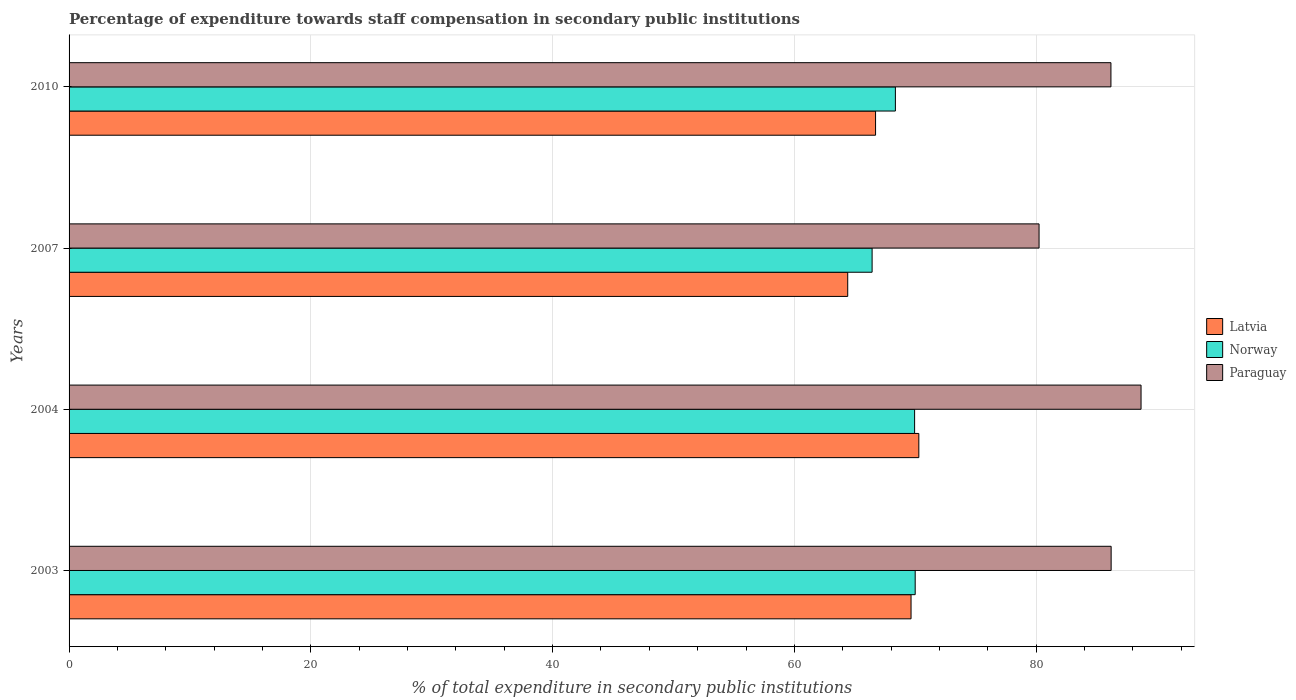How many different coloured bars are there?
Keep it short and to the point. 3. How many groups of bars are there?
Provide a succinct answer. 4. Are the number of bars per tick equal to the number of legend labels?
Your answer should be compact. Yes. Are the number of bars on each tick of the Y-axis equal?
Offer a very short reply. Yes. What is the label of the 3rd group of bars from the top?
Give a very brief answer. 2004. What is the percentage of expenditure towards staff compensation in Latvia in 2003?
Ensure brevity in your answer.  69.65. Across all years, what is the maximum percentage of expenditure towards staff compensation in Norway?
Your answer should be compact. 70. Across all years, what is the minimum percentage of expenditure towards staff compensation in Norway?
Your answer should be very brief. 66.43. In which year was the percentage of expenditure towards staff compensation in Latvia maximum?
Offer a terse response. 2004. What is the total percentage of expenditure towards staff compensation in Latvia in the graph?
Your response must be concise. 271.08. What is the difference between the percentage of expenditure towards staff compensation in Paraguay in 2004 and that in 2010?
Keep it short and to the point. 2.49. What is the difference between the percentage of expenditure towards staff compensation in Latvia in 2010 and the percentage of expenditure towards staff compensation in Norway in 2003?
Ensure brevity in your answer.  -3.28. What is the average percentage of expenditure towards staff compensation in Latvia per year?
Offer a very short reply. 67.77. In the year 2007, what is the difference between the percentage of expenditure towards staff compensation in Norway and percentage of expenditure towards staff compensation in Latvia?
Make the answer very short. 2.02. What is the ratio of the percentage of expenditure towards staff compensation in Latvia in 2003 to that in 2004?
Ensure brevity in your answer.  0.99. Is the difference between the percentage of expenditure towards staff compensation in Norway in 2003 and 2010 greater than the difference between the percentage of expenditure towards staff compensation in Latvia in 2003 and 2010?
Offer a terse response. No. What is the difference between the highest and the second highest percentage of expenditure towards staff compensation in Paraguay?
Your answer should be compact. 2.47. What is the difference between the highest and the lowest percentage of expenditure towards staff compensation in Latvia?
Make the answer very short. 5.88. In how many years, is the percentage of expenditure towards staff compensation in Latvia greater than the average percentage of expenditure towards staff compensation in Latvia taken over all years?
Your response must be concise. 2. What does the 2nd bar from the top in 2003 represents?
Offer a terse response. Norway. What does the 2nd bar from the bottom in 2004 represents?
Your response must be concise. Norway. How many bars are there?
Give a very brief answer. 12. What is the difference between two consecutive major ticks on the X-axis?
Offer a very short reply. 20. Are the values on the major ticks of X-axis written in scientific E-notation?
Provide a short and direct response. No. Does the graph contain any zero values?
Offer a terse response. No. How many legend labels are there?
Your response must be concise. 3. What is the title of the graph?
Keep it short and to the point. Percentage of expenditure towards staff compensation in secondary public institutions. Does "Cameroon" appear as one of the legend labels in the graph?
Make the answer very short. No. What is the label or title of the X-axis?
Your answer should be compact. % of total expenditure in secondary public institutions. What is the label or title of the Y-axis?
Give a very brief answer. Years. What is the % of total expenditure in secondary public institutions of Latvia in 2003?
Keep it short and to the point. 69.65. What is the % of total expenditure in secondary public institutions of Norway in 2003?
Provide a short and direct response. 70. What is the % of total expenditure in secondary public institutions in Paraguay in 2003?
Offer a terse response. 86.21. What is the % of total expenditure in secondary public institutions in Latvia in 2004?
Make the answer very short. 70.3. What is the % of total expenditure in secondary public institutions of Norway in 2004?
Keep it short and to the point. 69.95. What is the % of total expenditure in secondary public institutions in Paraguay in 2004?
Provide a succinct answer. 88.68. What is the % of total expenditure in secondary public institutions of Latvia in 2007?
Your answer should be compact. 64.41. What is the % of total expenditure in secondary public institutions in Norway in 2007?
Provide a short and direct response. 66.43. What is the % of total expenditure in secondary public institutions in Paraguay in 2007?
Your response must be concise. 80.24. What is the % of total expenditure in secondary public institutions in Latvia in 2010?
Provide a short and direct response. 66.72. What is the % of total expenditure in secondary public institutions of Norway in 2010?
Your answer should be compact. 68.36. What is the % of total expenditure in secondary public institutions of Paraguay in 2010?
Provide a short and direct response. 86.19. Across all years, what is the maximum % of total expenditure in secondary public institutions of Latvia?
Give a very brief answer. 70.3. Across all years, what is the maximum % of total expenditure in secondary public institutions in Norway?
Your response must be concise. 70. Across all years, what is the maximum % of total expenditure in secondary public institutions of Paraguay?
Make the answer very short. 88.68. Across all years, what is the minimum % of total expenditure in secondary public institutions of Latvia?
Your answer should be compact. 64.41. Across all years, what is the minimum % of total expenditure in secondary public institutions in Norway?
Keep it short and to the point. 66.43. Across all years, what is the minimum % of total expenditure in secondary public institutions in Paraguay?
Your answer should be compact. 80.24. What is the total % of total expenditure in secondary public institutions of Latvia in the graph?
Keep it short and to the point. 271.08. What is the total % of total expenditure in secondary public institutions in Norway in the graph?
Offer a very short reply. 274.73. What is the total % of total expenditure in secondary public institutions of Paraguay in the graph?
Give a very brief answer. 341.31. What is the difference between the % of total expenditure in secondary public institutions of Latvia in 2003 and that in 2004?
Ensure brevity in your answer.  -0.64. What is the difference between the % of total expenditure in secondary public institutions of Norway in 2003 and that in 2004?
Your answer should be very brief. 0.05. What is the difference between the % of total expenditure in secondary public institutions of Paraguay in 2003 and that in 2004?
Make the answer very short. -2.47. What is the difference between the % of total expenditure in secondary public institutions of Latvia in 2003 and that in 2007?
Ensure brevity in your answer.  5.24. What is the difference between the % of total expenditure in secondary public institutions of Norway in 2003 and that in 2007?
Provide a succinct answer. 3.56. What is the difference between the % of total expenditure in secondary public institutions of Paraguay in 2003 and that in 2007?
Your answer should be very brief. 5.96. What is the difference between the % of total expenditure in secondary public institutions in Latvia in 2003 and that in 2010?
Offer a very short reply. 2.94. What is the difference between the % of total expenditure in secondary public institutions of Norway in 2003 and that in 2010?
Your answer should be compact. 1.64. What is the difference between the % of total expenditure in secondary public institutions in Paraguay in 2003 and that in 2010?
Your response must be concise. 0.02. What is the difference between the % of total expenditure in secondary public institutions of Latvia in 2004 and that in 2007?
Your response must be concise. 5.88. What is the difference between the % of total expenditure in secondary public institutions in Norway in 2004 and that in 2007?
Provide a succinct answer. 3.52. What is the difference between the % of total expenditure in secondary public institutions in Paraguay in 2004 and that in 2007?
Give a very brief answer. 8.44. What is the difference between the % of total expenditure in secondary public institutions in Latvia in 2004 and that in 2010?
Provide a short and direct response. 3.58. What is the difference between the % of total expenditure in secondary public institutions in Norway in 2004 and that in 2010?
Keep it short and to the point. 1.59. What is the difference between the % of total expenditure in secondary public institutions in Paraguay in 2004 and that in 2010?
Make the answer very short. 2.49. What is the difference between the % of total expenditure in secondary public institutions of Latvia in 2007 and that in 2010?
Keep it short and to the point. -2.3. What is the difference between the % of total expenditure in secondary public institutions of Norway in 2007 and that in 2010?
Ensure brevity in your answer.  -1.93. What is the difference between the % of total expenditure in secondary public institutions in Paraguay in 2007 and that in 2010?
Make the answer very short. -5.95. What is the difference between the % of total expenditure in secondary public institutions in Latvia in 2003 and the % of total expenditure in secondary public institutions in Norway in 2004?
Provide a succinct answer. -0.29. What is the difference between the % of total expenditure in secondary public institutions of Latvia in 2003 and the % of total expenditure in secondary public institutions of Paraguay in 2004?
Your response must be concise. -19.03. What is the difference between the % of total expenditure in secondary public institutions of Norway in 2003 and the % of total expenditure in secondary public institutions of Paraguay in 2004?
Provide a short and direct response. -18.68. What is the difference between the % of total expenditure in secondary public institutions of Latvia in 2003 and the % of total expenditure in secondary public institutions of Norway in 2007?
Your response must be concise. 3.22. What is the difference between the % of total expenditure in secondary public institutions in Latvia in 2003 and the % of total expenditure in secondary public institutions in Paraguay in 2007?
Offer a very short reply. -10.59. What is the difference between the % of total expenditure in secondary public institutions in Norway in 2003 and the % of total expenditure in secondary public institutions in Paraguay in 2007?
Offer a very short reply. -10.25. What is the difference between the % of total expenditure in secondary public institutions in Latvia in 2003 and the % of total expenditure in secondary public institutions in Norway in 2010?
Keep it short and to the point. 1.3. What is the difference between the % of total expenditure in secondary public institutions of Latvia in 2003 and the % of total expenditure in secondary public institutions of Paraguay in 2010?
Ensure brevity in your answer.  -16.54. What is the difference between the % of total expenditure in secondary public institutions in Norway in 2003 and the % of total expenditure in secondary public institutions in Paraguay in 2010?
Provide a succinct answer. -16.19. What is the difference between the % of total expenditure in secondary public institutions in Latvia in 2004 and the % of total expenditure in secondary public institutions in Norway in 2007?
Give a very brief answer. 3.87. What is the difference between the % of total expenditure in secondary public institutions in Latvia in 2004 and the % of total expenditure in secondary public institutions in Paraguay in 2007?
Ensure brevity in your answer.  -9.95. What is the difference between the % of total expenditure in secondary public institutions in Norway in 2004 and the % of total expenditure in secondary public institutions in Paraguay in 2007?
Provide a succinct answer. -10.3. What is the difference between the % of total expenditure in secondary public institutions of Latvia in 2004 and the % of total expenditure in secondary public institutions of Norway in 2010?
Ensure brevity in your answer.  1.94. What is the difference between the % of total expenditure in secondary public institutions in Latvia in 2004 and the % of total expenditure in secondary public institutions in Paraguay in 2010?
Your answer should be very brief. -15.89. What is the difference between the % of total expenditure in secondary public institutions of Norway in 2004 and the % of total expenditure in secondary public institutions of Paraguay in 2010?
Give a very brief answer. -16.24. What is the difference between the % of total expenditure in secondary public institutions in Latvia in 2007 and the % of total expenditure in secondary public institutions in Norway in 2010?
Make the answer very short. -3.94. What is the difference between the % of total expenditure in secondary public institutions in Latvia in 2007 and the % of total expenditure in secondary public institutions in Paraguay in 2010?
Your answer should be very brief. -21.77. What is the difference between the % of total expenditure in secondary public institutions of Norway in 2007 and the % of total expenditure in secondary public institutions of Paraguay in 2010?
Ensure brevity in your answer.  -19.76. What is the average % of total expenditure in secondary public institutions of Latvia per year?
Give a very brief answer. 67.77. What is the average % of total expenditure in secondary public institutions in Norway per year?
Your response must be concise. 68.68. What is the average % of total expenditure in secondary public institutions in Paraguay per year?
Offer a very short reply. 85.33. In the year 2003, what is the difference between the % of total expenditure in secondary public institutions in Latvia and % of total expenditure in secondary public institutions in Norway?
Make the answer very short. -0.34. In the year 2003, what is the difference between the % of total expenditure in secondary public institutions in Latvia and % of total expenditure in secondary public institutions in Paraguay?
Make the answer very short. -16.55. In the year 2003, what is the difference between the % of total expenditure in secondary public institutions of Norway and % of total expenditure in secondary public institutions of Paraguay?
Offer a very short reply. -16.21. In the year 2004, what is the difference between the % of total expenditure in secondary public institutions in Latvia and % of total expenditure in secondary public institutions in Norway?
Your response must be concise. 0.35. In the year 2004, what is the difference between the % of total expenditure in secondary public institutions of Latvia and % of total expenditure in secondary public institutions of Paraguay?
Your answer should be compact. -18.38. In the year 2004, what is the difference between the % of total expenditure in secondary public institutions in Norway and % of total expenditure in secondary public institutions in Paraguay?
Provide a short and direct response. -18.73. In the year 2007, what is the difference between the % of total expenditure in secondary public institutions in Latvia and % of total expenditure in secondary public institutions in Norway?
Offer a terse response. -2.02. In the year 2007, what is the difference between the % of total expenditure in secondary public institutions in Latvia and % of total expenditure in secondary public institutions in Paraguay?
Your answer should be compact. -15.83. In the year 2007, what is the difference between the % of total expenditure in secondary public institutions in Norway and % of total expenditure in secondary public institutions in Paraguay?
Your answer should be compact. -13.81. In the year 2010, what is the difference between the % of total expenditure in secondary public institutions in Latvia and % of total expenditure in secondary public institutions in Norway?
Your answer should be compact. -1.64. In the year 2010, what is the difference between the % of total expenditure in secondary public institutions of Latvia and % of total expenditure in secondary public institutions of Paraguay?
Your answer should be compact. -19.47. In the year 2010, what is the difference between the % of total expenditure in secondary public institutions of Norway and % of total expenditure in secondary public institutions of Paraguay?
Provide a short and direct response. -17.83. What is the ratio of the % of total expenditure in secondary public institutions in Norway in 2003 to that in 2004?
Offer a terse response. 1. What is the ratio of the % of total expenditure in secondary public institutions of Paraguay in 2003 to that in 2004?
Offer a terse response. 0.97. What is the ratio of the % of total expenditure in secondary public institutions in Latvia in 2003 to that in 2007?
Your answer should be compact. 1.08. What is the ratio of the % of total expenditure in secondary public institutions of Norway in 2003 to that in 2007?
Make the answer very short. 1.05. What is the ratio of the % of total expenditure in secondary public institutions of Paraguay in 2003 to that in 2007?
Offer a terse response. 1.07. What is the ratio of the % of total expenditure in secondary public institutions in Latvia in 2003 to that in 2010?
Ensure brevity in your answer.  1.04. What is the ratio of the % of total expenditure in secondary public institutions in Latvia in 2004 to that in 2007?
Make the answer very short. 1.09. What is the ratio of the % of total expenditure in secondary public institutions in Norway in 2004 to that in 2007?
Ensure brevity in your answer.  1.05. What is the ratio of the % of total expenditure in secondary public institutions of Paraguay in 2004 to that in 2007?
Offer a very short reply. 1.11. What is the ratio of the % of total expenditure in secondary public institutions in Latvia in 2004 to that in 2010?
Offer a very short reply. 1.05. What is the ratio of the % of total expenditure in secondary public institutions of Norway in 2004 to that in 2010?
Your answer should be compact. 1.02. What is the ratio of the % of total expenditure in secondary public institutions of Paraguay in 2004 to that in 2010?
Offer a terse response. 1.03. What is the ratio of the % of total expenditure in secondary public institutions of Latvia in 2007 to that in 2010?
Provide a short and direct response. 0.97. What is the ratio of the % of total expenditure in secondary public institutions of Norway in 2007 to that in 2010?
Offer a terse response. 0.97. What is the ratio of the % of total expenditure in secondary public institutions of Paraguay in 2007 to that in 2010?
Offer a terse response. 0.93. What is the difference between the highest and the second highest % of total expenditure in secondary public institutions of Latvia?
Keep it short and to the point. 0.64. What is the difference between the highest and the second highest % of total expenditure in secondary public institutions of Norway?
Offer a very short reply. 0.05. What is the difference between the highest and the second highest % of total expenditure in secondary public institutions in Paraguay?
Your answer should be very brief. 2.47. What is the difference between the highest and the lowest % of total expenditure in secondary public institutions of Latvia?
Your response must be concise. 5.88. What is the difference between the highest and the lowest % of total expenditure in secondary public institutions in Norway?
Your response must be concise. 3.56. What is the difference between the highest and the lowest % of total expenditure in secondary public institutions of Paraguay?
Give a very brief answer. 8.44. 